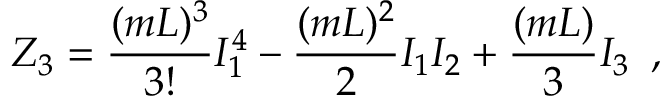Convert formula to latex. <formula><loc_0><loc_0><loc_500><loc_500>Z _ { 3 } = \frac { ( m L ) ^ { 3 } } { 3 ! } I _ { 1 } ^ { 4 } - \frac { ( m L ) ^ { 2 } } { 2 } I _ { 1 } I _ { 2 } + \frac { ( m L ) } { 3 } I _ { 3 } \, ,</formula> 